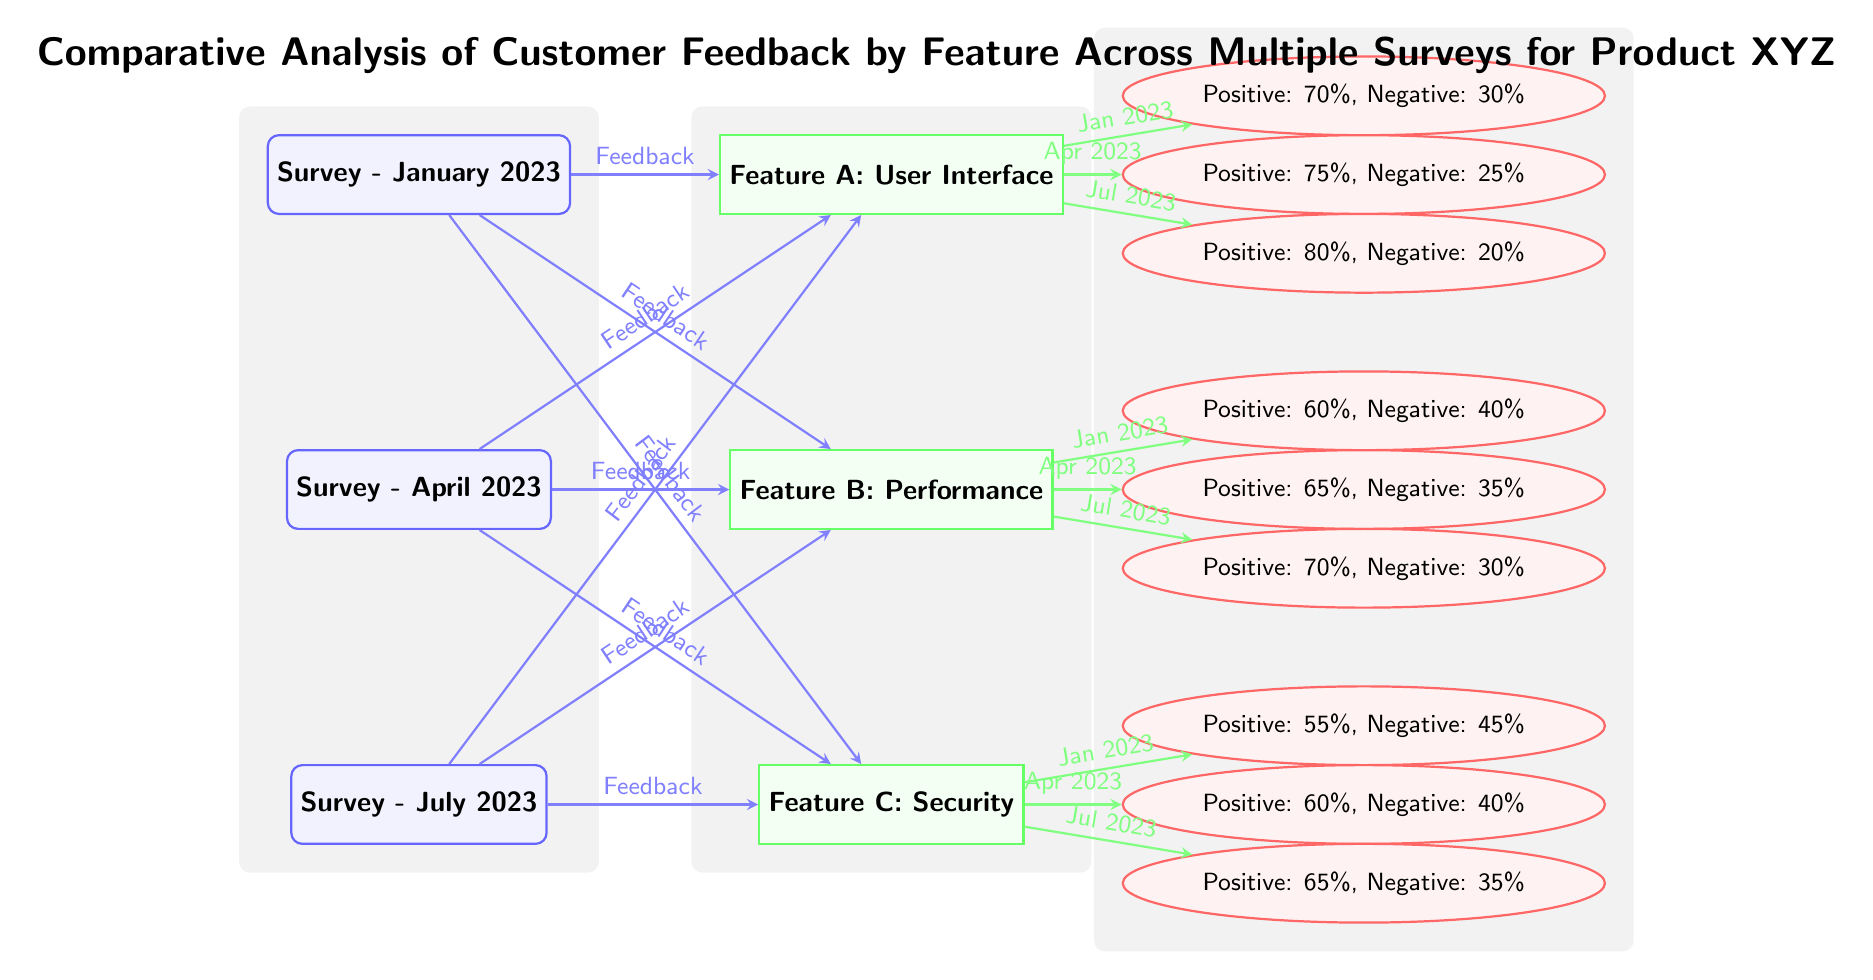What is the percentage of positive feedback for Feature A in July 2023? The diagram shows that for Feature A in July 2023, the feedback is coded in the node fb1_3. Looking at the node, it states that the positive feedback is 80%.
Answer: 80% Which feature has the most positive feedback from the survey conducted in January 2023? For January 2023, we need to look at the feedback nodes connected to Feature A, Feature B, and Feature C. The positives for Feature A are 70%, for Feature B are 60%, and for Feature C are 55%. The highest is Feature A with 70%.
Answer: Feature A What is the negative feedback percentage for Feature B in April 2023? The node fb2_2 represents the feedback for Feature B in April 2023. The feedback shows a negative percentage of 35%.
Answer: 35% How many total surveys are represented in the diagram? The diagram shows three surveys: January 2023, April 2023, and July 2023. By counting the survey nodes, we confirm there are 3 surveys.
Answer: 3 Which feature received the lowest positive feedback overall across all surveys? To find the lowest positive feedback, we need to examine all features and their corresponding positive feedback percentages across all surveys. For Feature A: 70%, 75%, 80%; Feature B: 60%, 65%, 70%; Feature C: 55%, 60%, 65%. Feature C has the lowest at 55%.
Answer: Feature C Which survey had the highest positive feedback for Feature C? Looking at the feedback for Feature C across the surveys: January has 55%, April has 60%, and July has 65%. The highest is in July 2023, yielding 65% positive feedback.
Answer: July 2023 What is the label for the connection from Survey - April 2023 to Feature A? The arrow connecting Survey - April 2023 to Feature A is labeled "Feedback".
Answer: Feedback What is the overall trend in positive feedback for Feature B from January 2023 to July 2023? The feedback percentages for Feature B are as follows: January (60%), April (65%), and July (70%). This shows a consistent increase in positive feedback over the surveyed months.
Answer: Increasing 